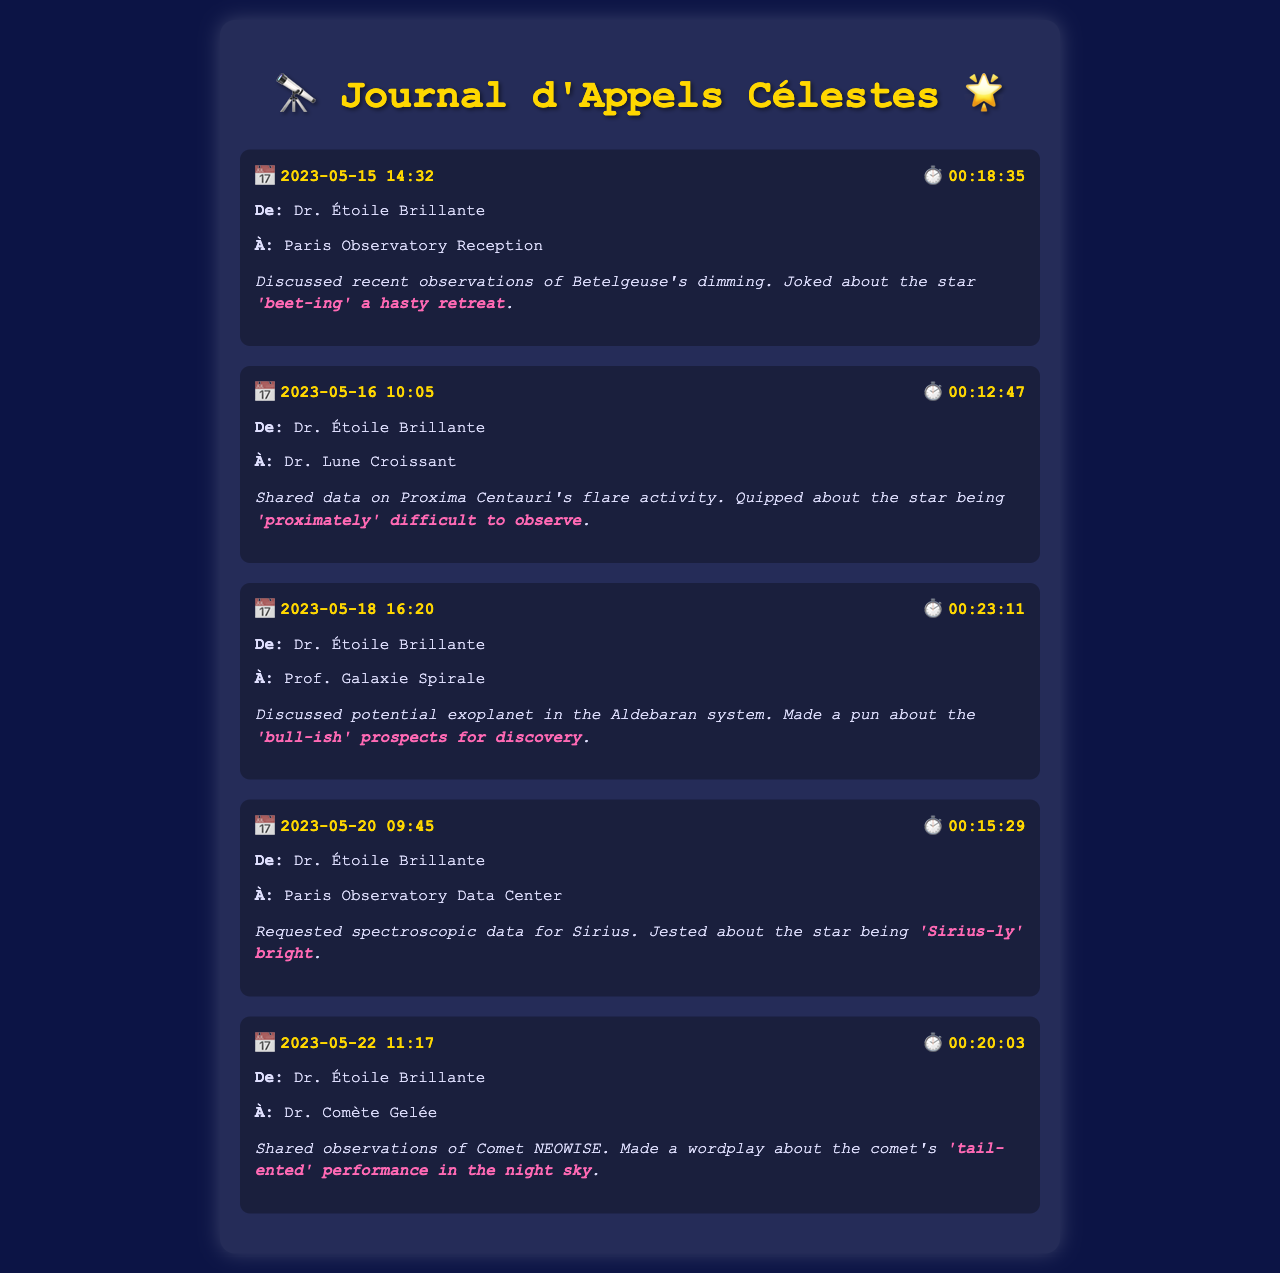What is the date of the first call? The first call is logged on May 15, 2023.
Answer: May 15, 2023 Who was Dr. Étoile Brillante discussing with regarding Proxima Centauri? Dr. Étoile Brillante spoke with Dr. Lune Croissant about Proxima Centauri's flare activity.
Answer: Dr. Lune Croissant What pun did Dr. Étoile Brillante make about Sirius? The pun made was about Sirius being "Sirius-ly' bright."
Answer: 'Sirius-ly' bright How long was the call on May 20, 2023? The duration of the call on May 20, 2023, was 00:15:29.
Answer: 00:15:29 What celestial object was discussed in the call on May 22, 2023? The call on May 22, 2023, involved observations of Comet NEOWISE.
Answer: Comet NEOWISE Who received the call on May 18 regarding the Aldebaran system? The call was received by Prof. Galaxie Spirale.
Answer: Prof. Galaxie Spirale 